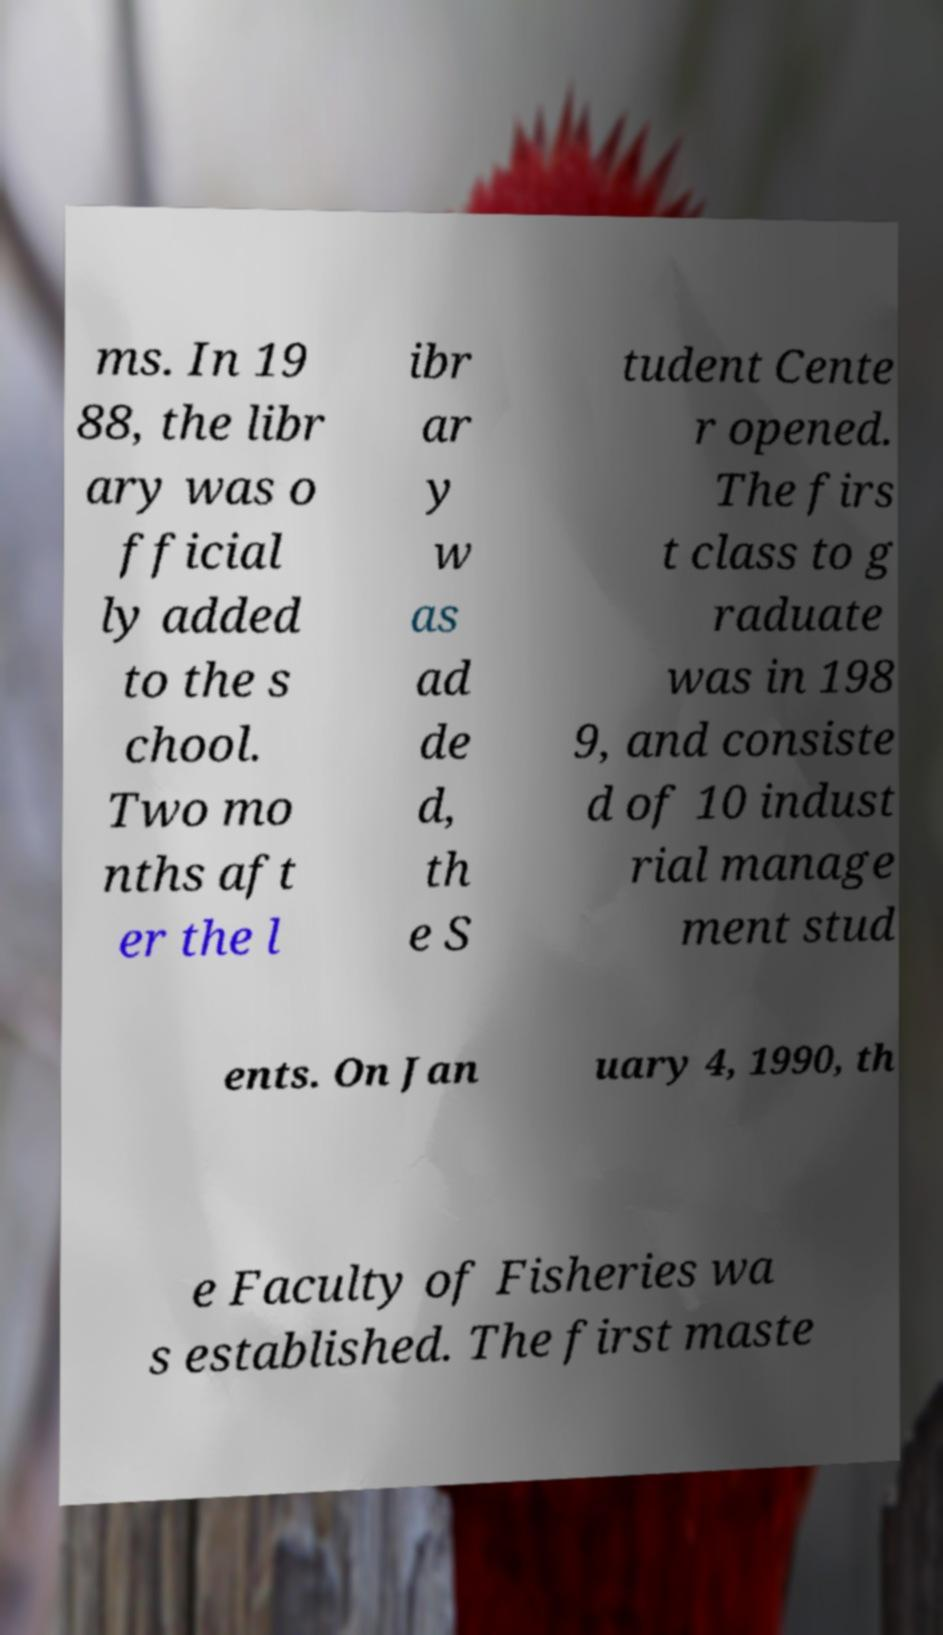Could you assist in decoding the text presented in this image and type it out clearly? ms. In 19 88, the libr ary was o fficial ly added to the s chool. Two mo nths aft er the l ibr ar y w as ad de d, th e S tudent Cente r opened. The firs t class to g raduate was in 198 9, and consiste d of 10 indust rial manage ment stud ents. On Jan uary 4, 1990, th e Faculty of Fisheries wa s established. The first maste 